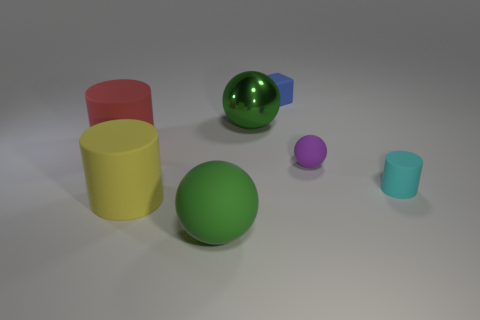There is a matte thing that is the same color as the metal sphere; what is its shape?
Provide a succinct answer. Sphere. What is the color of the large matte cylinder in front of the large red cylinder?
Your response must be concise. Yellow. Are there the same number of red matte things that are behind the red matte cylinder and big green objects in front of the green shiny object?
Give a very brief answer. No. What material is the tiny thing that is behind the matte cylinder that is on the left side of the large yellow thing made of?
Provide a succinct answer. Rubber. What number of objects are either big red cylinders or red rubber cylinders that are in front of the cube?
Your response must be concise. 1. What is the size of the purple object that is made of the same material as the cyan object?
Your answer should be compact. Small. Are there more big rubber cylinders that are on the left side of the yellow object than large yellow metal cubes?
Your answer should be compact. Yes. What size is the thing that is both to the right of the green shiny sphere and behind the red thing?
Provide a succinct answer. Small. There is another green thing that is the same shape as the green matte thing; what is it made of?
Ensure brevity in your answer.  Metal. There is a rubber cylinder that is right of the purple matte sphere; does it have the same size as the blue matte cube?
Give a very brief answer. Yes. 